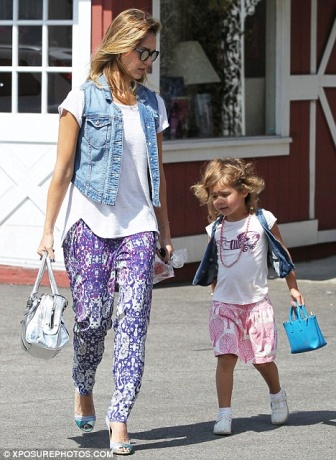What's the history of the area they are walking in? The area they are walking in appears to be a historic part of town, with charming old buildings that have seen many generations. The red building with white trim suggests a timeless design, possibly from the early 20th century, when craftsmanship and aesthetic details were paramount. This locality might have been a bustling market area in the past, with small family-owned shops and cafés that have been maintained through the years. Now, it serves as a serene reminder of the town’s rich history and cultural heritage. How might their day conclude after this walk? After their walk, they might head home to unwind. The little girl could excitedly show her new purchases to her siblings or father, while the mother starts preparing dinner. They enjoy a meal together, sharing stories about their day. Afterwards, they might settle in the living room for a quiet evening, the mother with a book and the daughter playing with her new toys. The day concludes with bedtime stories, laughter, and a feeling of contentment. 